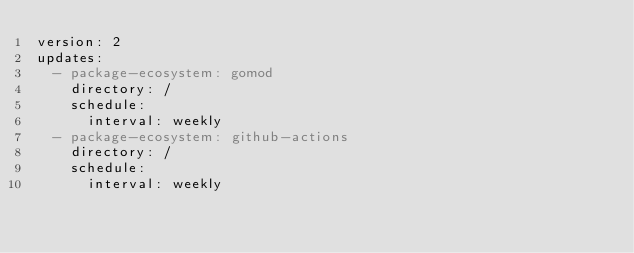Convert code to text. <code><loc_0><loc_0><loc_500><loc_500><_YAML_>version: 2
updates:
  - package-ecosystem: gomod
    directory: /
    schedule:
      interval: weekly
  - package-ecosystem: github-actions
    directory: /
    schedule:
      interval: weekly</code> 